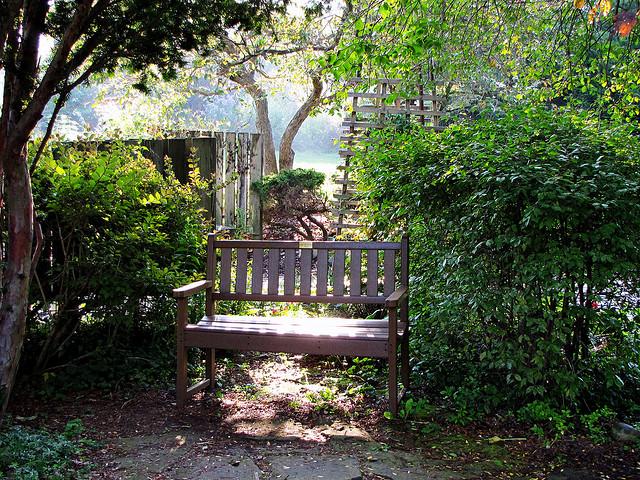What type of chair is the bear sitting in?
Be succinct. None. Is this a park?
Write a very short answer. Yes. Could two people fit on that seat?
Give a very brief answer. Yes. 